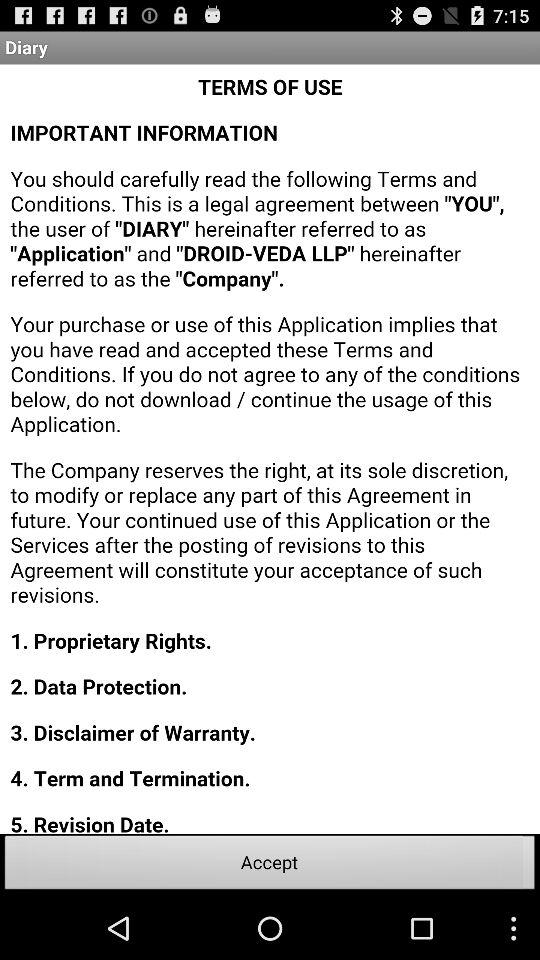How many terms are in the agreement?
Answer the question using a single word or phrase. 5 